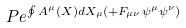Convert formula to latex. <formula><loc_0><loc_0><loc_500><loc_500>P e ^ { \oint A ^ { \mu } ( X ) d X _ { \mu } ( + F _ { \mu \nu } \psi ^ { \mu } \psi ^ { \nu } ) }</formula> 